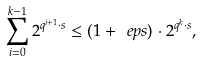Convert formula to latex. <formula><loc_0><loc_0><loc_500><loc_500>\sum _ { i = 0 } ^ { k - 1 } 2 ^ { q ^ { i + 1 } \cdot s } \leq ( 1 + \ e p s ) \cdot 2 ^ { q ^ { k } \cdot s } ,</formula> 